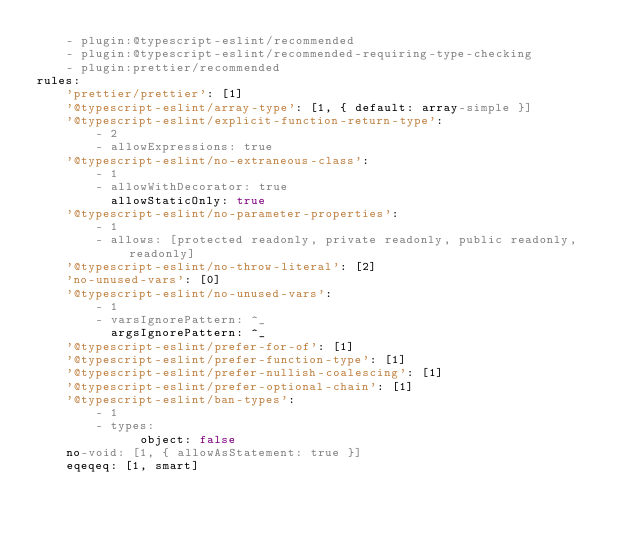Convert code to text. <code><loc_0><loc_0><loc_500><loc_500><_YAML_>    - plugin:@typescript-eslint/recommended
    - plugin:@typescript-eslint/recommended-requiring-type-checking
    - plugin:prettier/recommended
rules:
    'prettier/prettier': [1]
    '@typescript-eslint/array-type': [1, { default: array-simple }]
    '@typescript-eslint/explicit-function-return-type':
        - 2
        - allowExpressions: true
    '@typescript-eslint/no-extraneous-class':
        - 1
        - allowWithDecorator: true
          allowStaticOnly: true
    '@typescript-eslint/no-parameter-properties':
        - 1
        - allows: [protected readonly, private readonly, public readonly, readonly]
    '@typescript-eslint/no-throw-literal': [2]
    'no-unused-vars': [0]
    '@typescript-eslint/no-unused-vars':
        - 1
        - varsIgnorePattern: ^_
          argsIgnorePattern: ^_
    '@typescript-eslint/prefer-for-of': [1]
    '@typescript-eslint/prefer-function-type': [1]
    '@typescript-eslint/prefer-nullish-coalescing': [1]
    '@typescript-eslint/prefer-optional-chain': [1]
    '@typescript-eslint/ban-types':
        - 1
        - types:
              object: false
    no-void: [1, { allowAsStatement: true }]
    eqeqeq: [1, smart]
</code> 